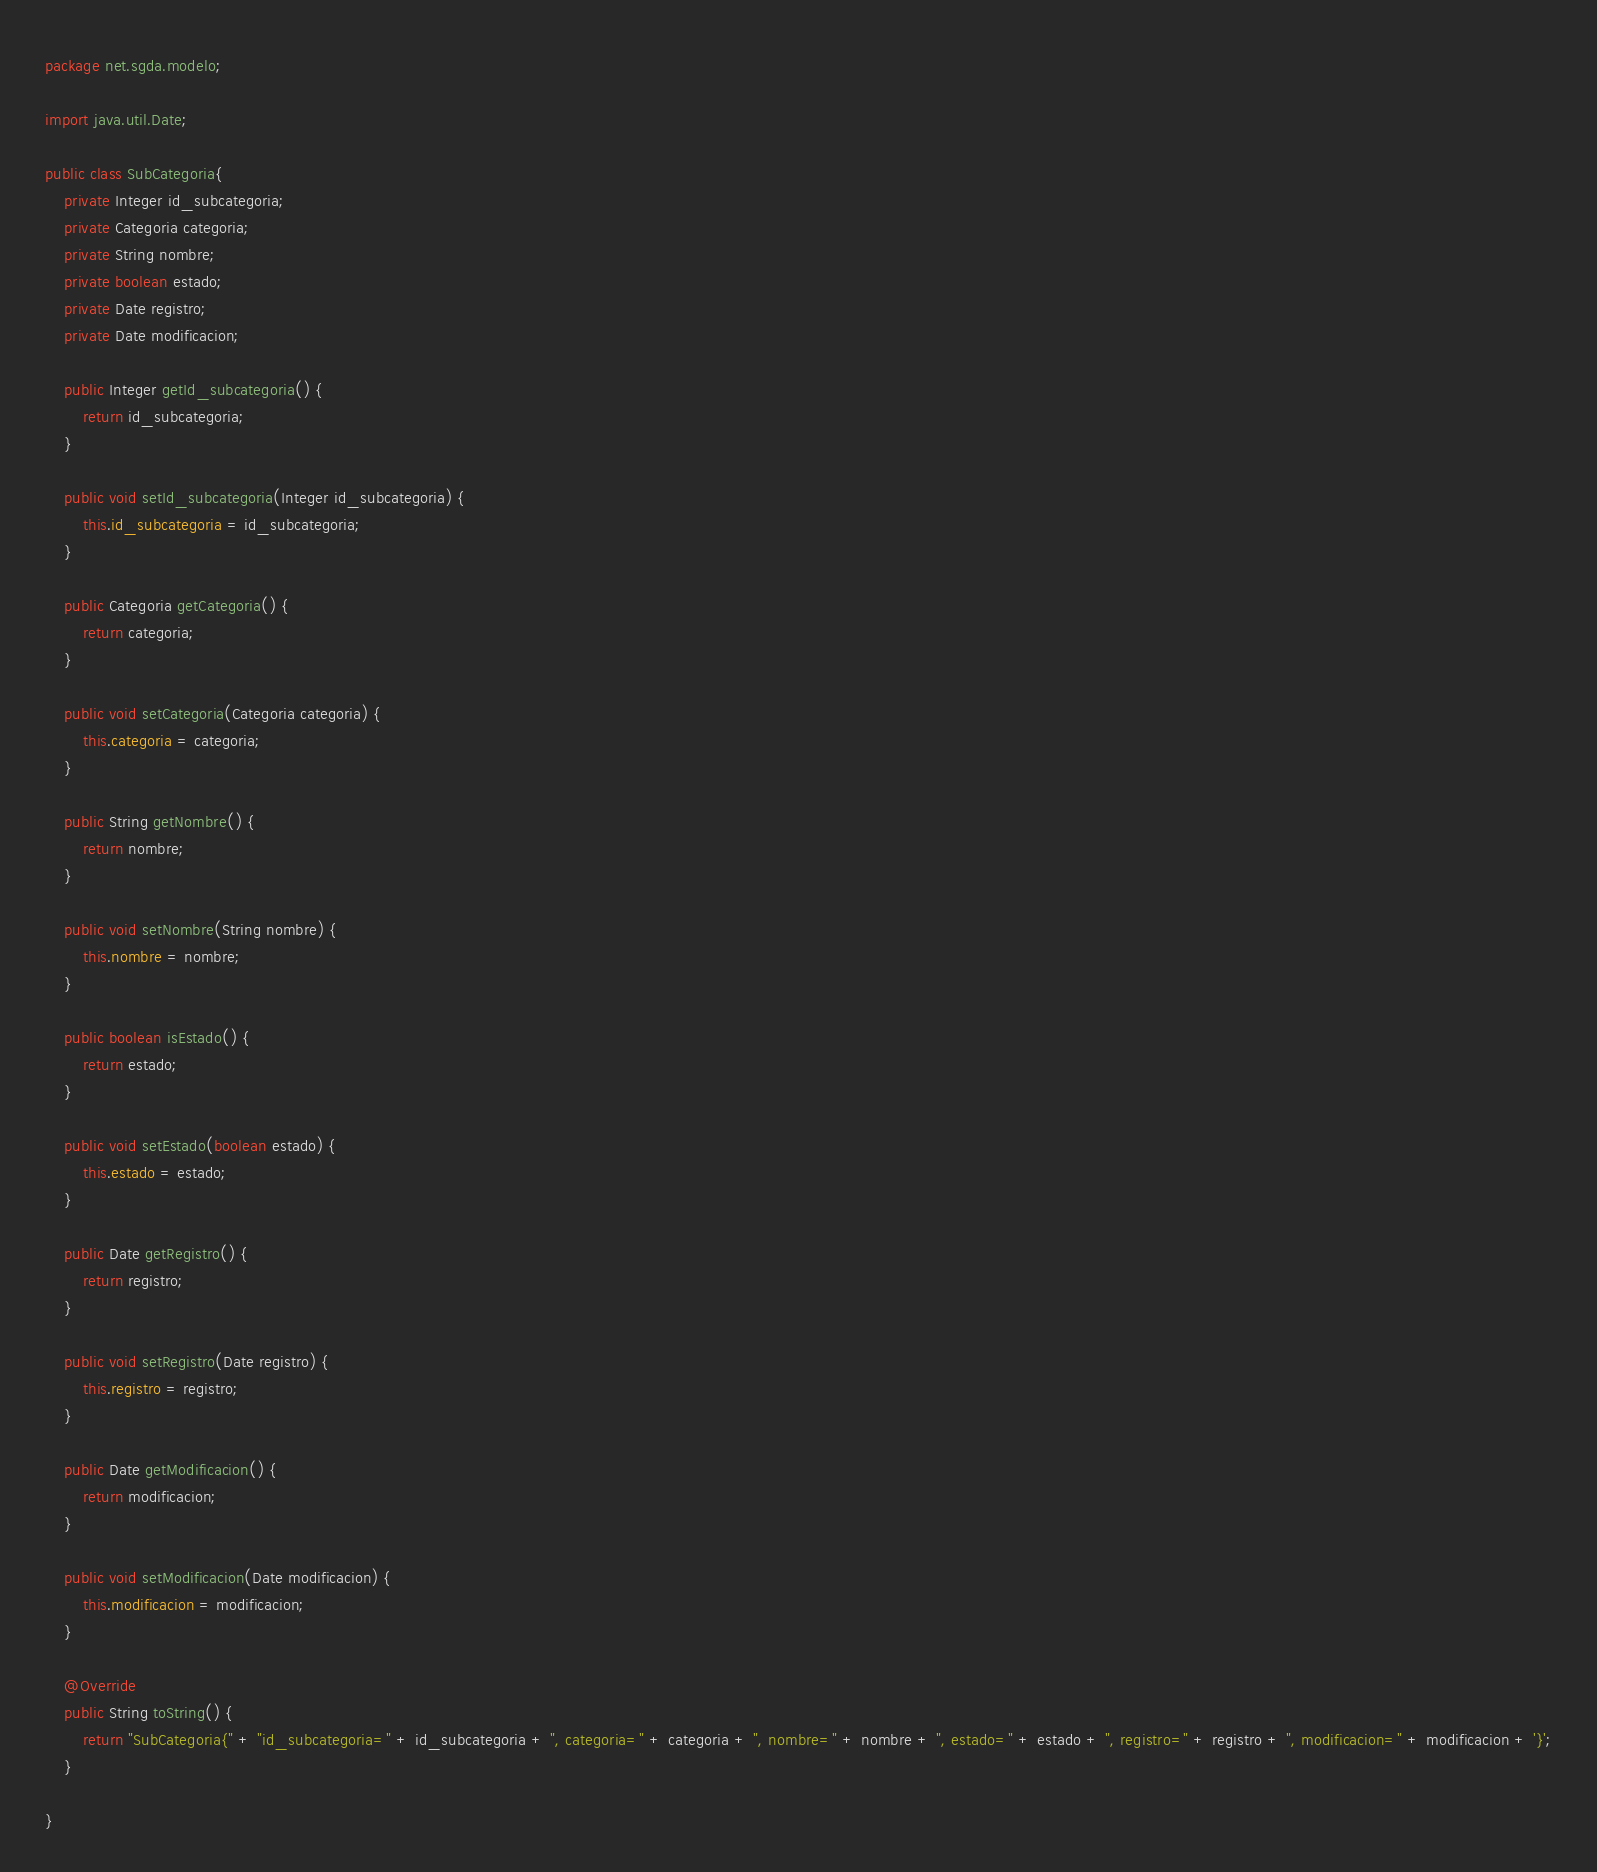Convert code to text. <code><loc_0><loc_0><loc_500><loc_500><_Java_>package net.sgda.modelo;

import java.util.Date;

public class SubCategoria{
    private Integer id_subcategoria;
    private Categoria categoria;
    private String nombre;
    private boolean estado;
    private Date registro;
    private Date modificacion;

    public Integer getId_subcategoria() {
        return id_subcategoria;
    }

    public void setId_subcategoria(Integer id_subcategoria) {
        this.id_subcategoria = id_subcategoria;
    }

    public Categoria getCategoria() {
        return categoria;
    }

    public void setCategoria(Categoria categoria) {
        this.categoria = categoria;
    }

    public String getNombre() {
        return nombre;
    }

    public void setNombre(String nombre) {
        this.nombre = nombre;
    }

    public boolean isEstado() {
        return estado;
    }

    public void setEstado(boolean estado) {
        this.estado = estado;
    }

    public Date getRegistro() {
        return registro;
    }

    public void setRegistro(Date registro) {
        this.registro = registro;
    }

    public Date getModificacion() {
        return modificacion;
    }

    public void setModificacion(Date modificacion) {
        this.modificacion = modificacion;
    }

    @Override
    public String toString() {
        return "SubCategoria{" + "id_subcategoria=" + id_subcategoria + ", categoria=" + categoria + ", nombre=" + nombre + ", estado=" + estado + ", registro=" + registro + ", modificacion=" + modificacion + '}';
    }
    
}
</code> 